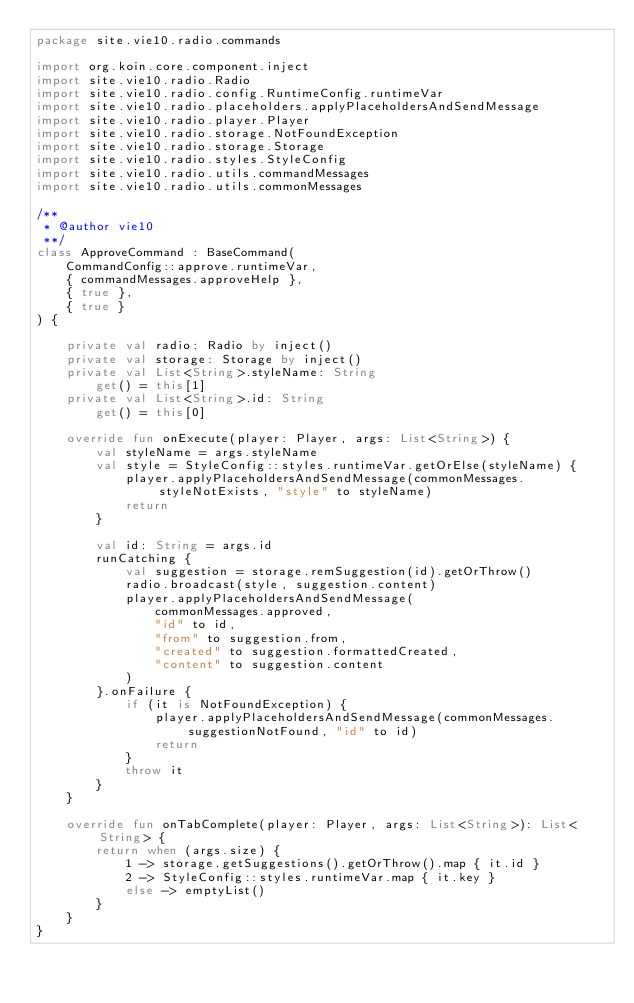<code> <loc_0><loc_0><loc_500><loc_500><_Kotlin_>package site.vie10.radio.commands

import org.koin.core.component.inject
import site.vie10.radio.Radio
import site.vie10.radio.config.RuntimeConfig.runtimeVar
import site.vie10.radio.placeholders.applyPlaceholdersAndSendMessage
import site.vie10.radio.player.Player
import site.vie10.radio.storage.NotFoundException
import site.vie10.radio.storage.Storage
import site.vie10.radio.styles.StyleConfig
import site.vie10.radio.utils.commandMessages
import site.vie10.radio.utils.commonMessages

/**
 * @author vie10
 **/
class ApproveCommand : BaseCommand(
    CommandConfig::approve.runtimeVar,
    { commandMessages.approveHelp },
    { true },
    { true }
) {

    private val radio: Radio by inject()
    private val storage: Storage by inject()
    private val List<String>.styleName: String
        get() = this[1]
    private val List<String>.id: String
        get() = this[0]

    override fun onExecute(player: Player, args: List<String>) {
        val styleName = args.styleName
        val style = StyleConfig::styles.runtimeVar.getOrElse(styleName) {
            player.applyPlaceholdersAndSendMessage(commonMessages.styleNotExists, "style" to styleName)
            return
        }

        val id: String = args.id
        runCatching {
            val suggestion = storage.remSuggestion(id).getOrThrow()
            radio.broadcast(style, suggestion.content)
            player.applyPlaceholdersAndSendMessage(
                commonMessages.approved,
                "id" to id,
                "from" to suggestion.from,
                "created" to suggestion.formattedCreated,
                "content" to suggestion.content
            )
        }.onFailure {
            if (it is NotFoundException) {
                player.applyPlaceholdersAndSendMessage(commonMessages.suggestionNotFound, "id" to id)
                return
            }
            throw it
        }
    }

    override fun onTabComplete(player: Player, args: List<String>): List<String> {
        return when (args.size) {
            1 -> storage.getSuggestions().getOrThrow().map { it.id }
            2 -> StyleConfig::styles.runtimeVar.map { it.key }
            else -> emptyList()
        }
    }
}
</code> 